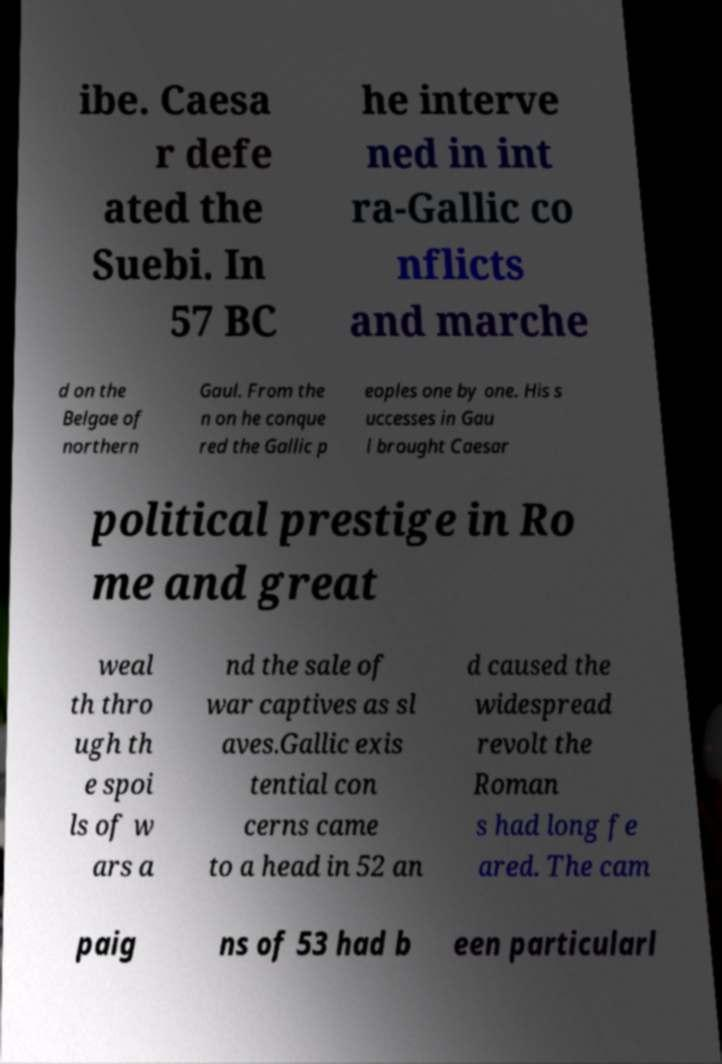I need the written content from this picture converted into text. Can you do that? ibe. Caesa r defe ated the Suebi. In 57 BC he interve ned in int ra-Gallic co nflicts and marche d on the Belgae of northern Gaul. From the n on he conque red the Gallic p eoples one by one. His s uccesses in Gau l brought Caesar political prestige in Ro me and great weal th thro ugh th e spoi ls of w ars a nd the sale of war captives as sl aves.Gallic exis tential con cerns came to a head in 52 an d caused the widespread revolt the Roman s had long fe ared. The cam paig ns of 53 had b een particularl 